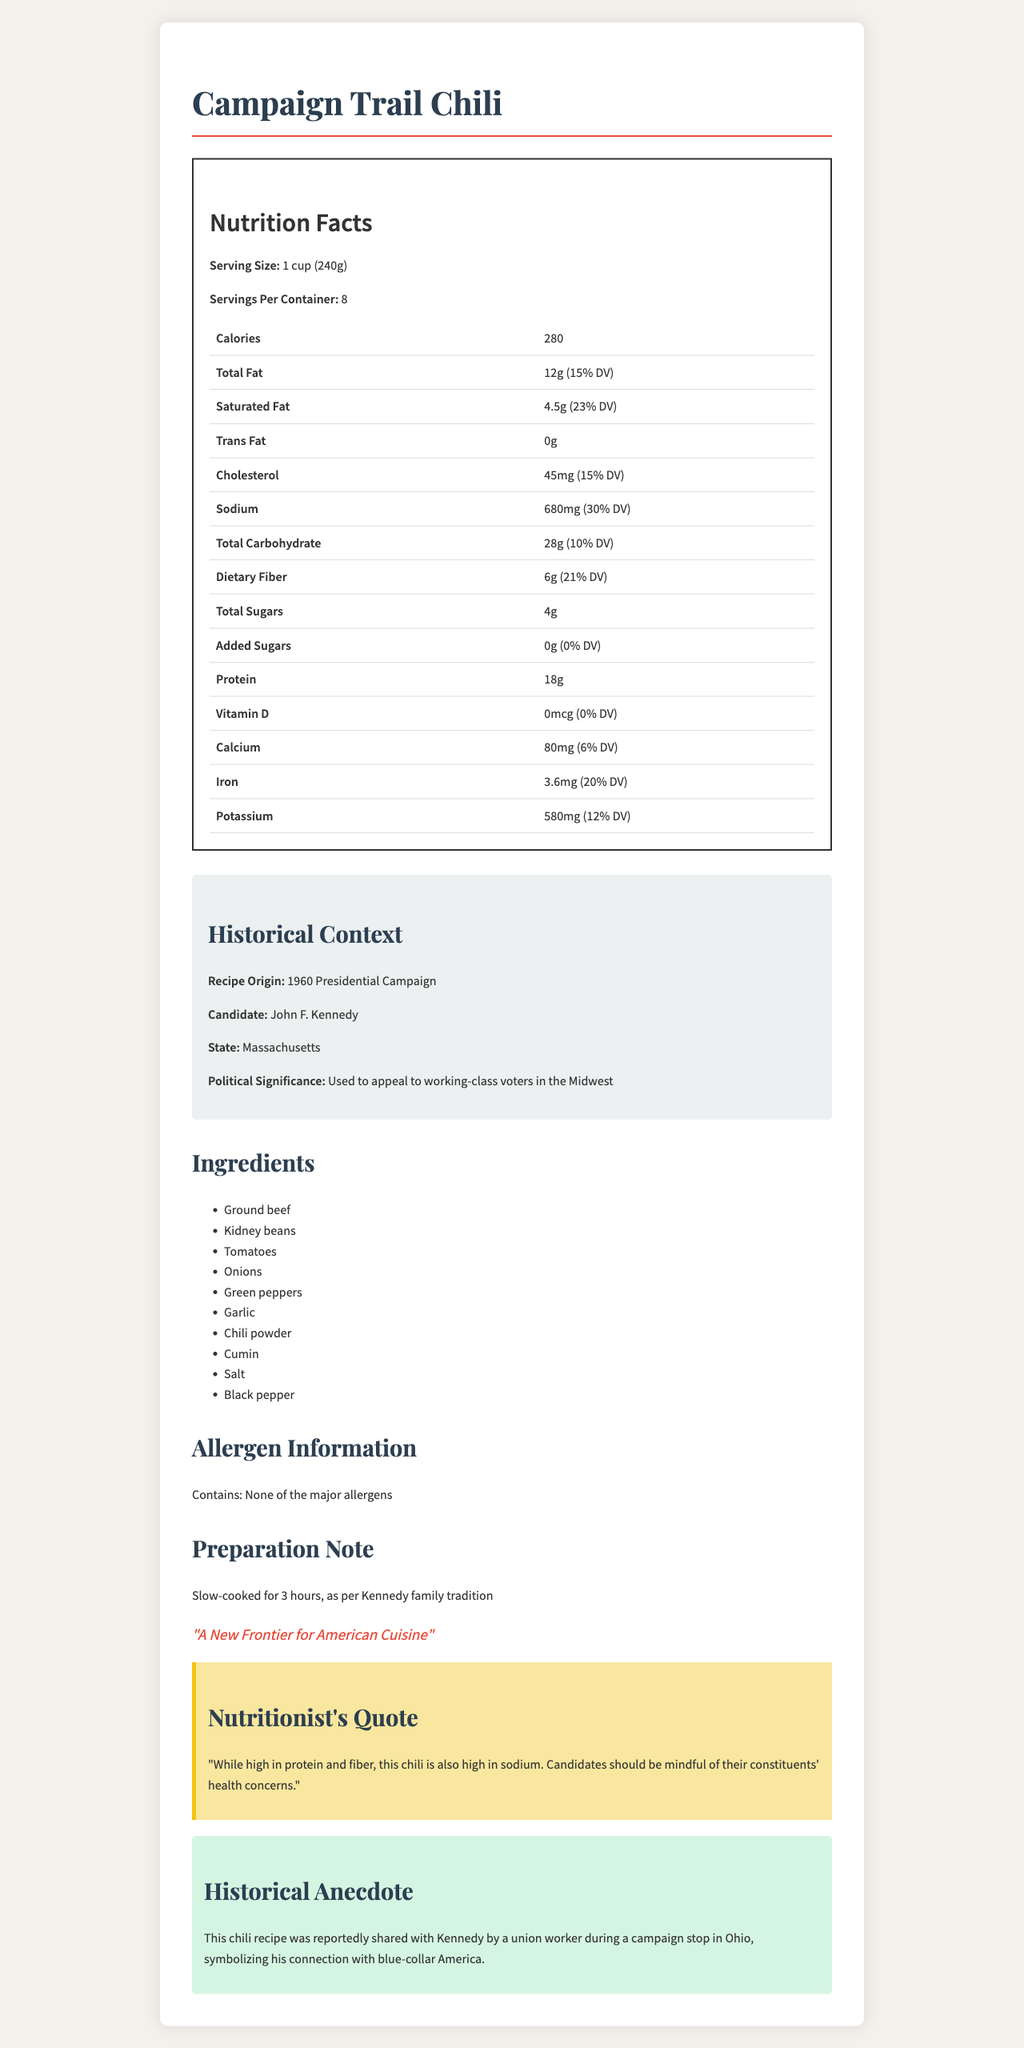what is the serving size of Campaign Trail Chili? The serving size is explicitly stated at the beginning of the nutrition facts label.
Answer: 1 cup (240g) how many calories are in one serving of Campaign Trail Chili? The calories per serving are listed directly in the nutrition facts label.
Answer: 280 how much saturated fat does Campaign Trail Chili contain? The amount of saturated fat per serving is detailed in the nutrition facts label.
Answer: 4.5g who was the candidate associated with this chili recipe? The historical context section states that the recipe is associated with John F. Kennedy.
Answer: John F. Kennedy what is the daily value percentage for iron per serving of Campaign Trail Chili? The nutrition facts label lists the iron content and its daily value percentage.
Answer: 20% which nutrient has the highest daily value percentage in Campaign Trail Chili? A. Total Fat B. Sodium C. Dietary Fiber D. Cholesterol Comparing the daily percentage values, dietary fiber has the highest at 21%.
Answer: C. Dietary Fiber what state is associated with the origins of the Campaign Trail Chili recipe? A. Massachusetts B. Ohio C. Texas D. New York The historical context indicates the recipe is from Massachusetts.
Answer: A. Massachusetts is there any trans fat in Campaign Trail Chili? The nutrition facts label shows 0g of trans fat.
Answer: No summarize the main idea of the document. The document combines nutritional information and historical context to present a comprehensive overview of the Campaign Trail Chili recipe.
Answer: The document provides the nutrition facts and historical context for Campaign Trail Chili, a recipe associated with John F. Kennedy's 1960 Presidential Campaign. The label includes details on serving size, calories, fat content, and other nutrients, as well as historical details about the candidate and campaign. who shared the chili recipe with Kennedy according to the anecdote? The historical anecdote mentions that a union worker shared the recipe with Kennedy.
Answer: A union worker can you determine the exact preparation method for the chili from the document? The preparation note states that the chili is slow-cooked for 3 hours, following Kennedy family tradition.
Answer: Yes how much sodium does one serving of Campaign Trail Chili contain? The amount of sodium per serving is listed in the nutrition facts label.
Answer: 680mg what is the significance of the chili recipe in Kennedy's campaign? The historical context explains that the chili was used to connect with working-class voters in the Midwest.
Answer: It was used to appeal to working-class voters in the Midwest. how much protein is in a serving? The nutrition facts label shows 18 grams of protein per serving.
Answer: 18g does the document provide information about the allergen content of the chili? The allergen information section indicates that it contains none of the major allergens.
Answer: Yes does the document mention anything about the chili's vitamin D content? The nutrition facts indicate 0mcg of vitamin D with 0% daily value.
Answer: Yes what percentage of the daily value of calcium does one serving of the chili provide? The nutrition facts label lists the calcium content and its daily value percentage.
Answer: 6% is the campaign slogan mentioned in the document? The slogan "A New Frontier for American Cuisine" is provided in the document.
Answer: Yes why should candidates be mindful of the chili's nutrient content according to the nutritionist's quote? The nutritionist's quote indicates a concern about the high sodium content.
Answer: Because the chili is high in sodium. what personal story is associated with the chili recipe? The document includes an anecdote about a union worker sharing the recipe with Kennedy, symbolizing his connection with blue-collar America.
Answer: A union worker reportedly shared the recipe with Kennedy during a campaign stop in Ohio. 